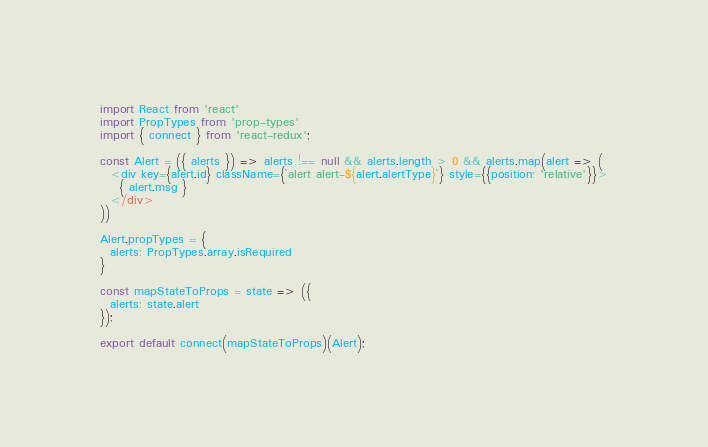<code> <loc_0><loc_0><loc_500><loc_500><_JavaScript_>import React from 'react'
import PropTypes from 'prop-types'
import { connect } from 'react-redux';

const Alert = ({ alerts }) => alerts !== null && alerts.length > 0 && alerts.map(alert => (
  <div key={alert.id} className={`alert alert-${alert.alertType}`} style={{position: 'relative'}}>
    { alert.msg }
  </div>
))

Alert.propTypes = {
  alerts: PropTypes.array.isRequired
}

const mapStateToProps = state => ({
  alerts: state.alert
});

export default connect(mapStateToProps)(Alert);
</code> 